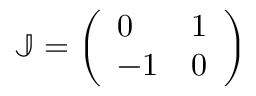Convert formula to latex. <formula><loc_0><loc_0><loc_500><loc_500>\mathbb { J } = \left ( \begin{array} { l l } { 0 } & { 1 } \\ { - 1 } & { 0 } \end{array} \right )</formula> 